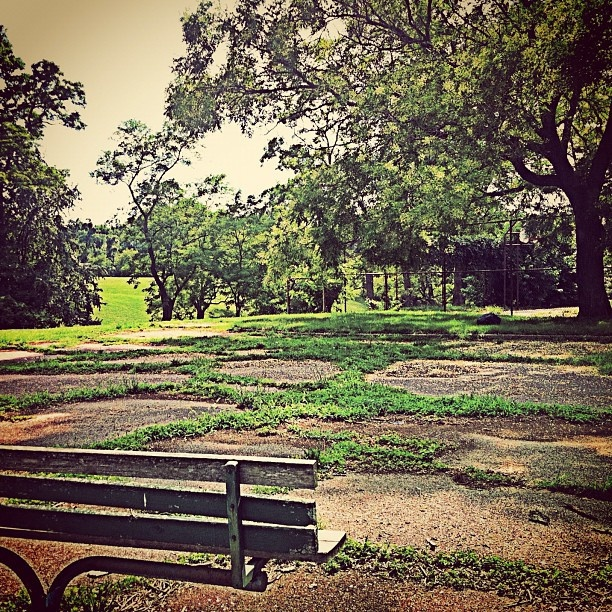Describe the objects in this image and their specific colors. I can see a bench in tan, black, gray, maroon, and beige tones in this image. 